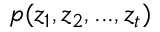Convert formula to latex. <formula><loc_0><loc_0><loc_500><loc_500>p ( z _ { 1 } , z _ { 2 } , \dots , z _ { t } )</formula> 